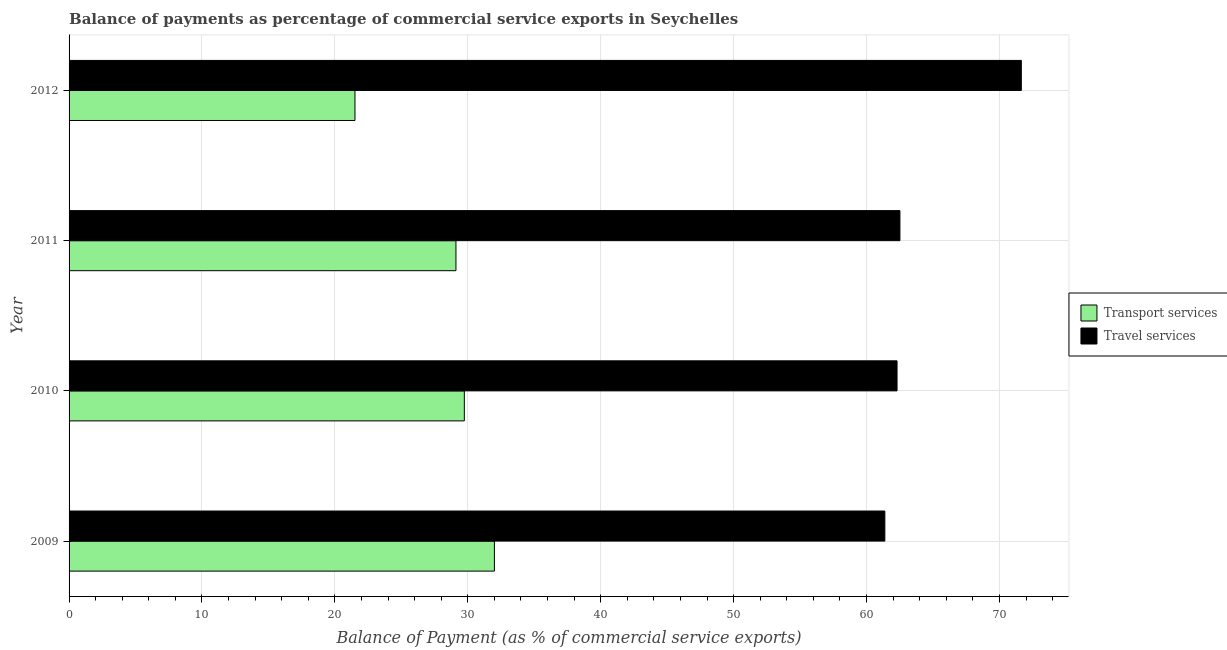How many different coloured bars are there?
Your answer should be compact. 2. Are the number of bars per tick equal to the number of legend labels?
Your answer should be compact. Yes. Are the number of bars on each tick of the Y-axis equal?
Your response must be concise. Yes. How many bars are there on the 3rd tick from the top?
Your answer should be very brief. 2. What is the balance of payments of travel services in 2011?
Your response must be concise. 62.51. Across all years, what is the maximum balance of payments of travel services?
Provide a succinct answer. 71.65. Across all years, what is the minimum balance of payments of travel services?
Provide a succinct answer. 61.38. What is the total balance of payments of transport services in the graph?
Your answer should be very brief. 112.36. What is the difference between the balance of payments of transport services in 2009 and that in 2010?
Keep it short and to the point. 2.26. What is the difference between the balance of payments of travel services in 2012 and the balance of payments of transport services in 2010?
Provide a succinct answer. 41.91. What is the average balance of payments of transport services per year?
Make the answer very short. 28.09. In the year 2011, what is the difference between the balance of payments of travel services and balance of payments of transport services?
Your answer should be very brief. 33.41. In how many years, is the balance of payments of travel services greater than 54 %?
Provide a short and direct response. 4. Is the difference between the balance of payments of transport services in 2011 and 2012 greater than the difference between the balance of payments of travel services in 2011 and 2012?
Your answer should be compact. Yes. What is the difference between the highest and the second highest balance of payments of travel services?
Your answer should be compact. 9.13. What is the difference between the highest and the lowest balance of payments of travel services?
Your answer should be compact. 10.27. In how many years, is the balance of payments of transport services greater than the average balance of payments of transport services taken over all years?
Your answer should be compact. 3. Is the sum of the balance of payments of transport services in 2009 and 2012 greater than the maximum balance of payments of travel services across all years?
Give a very brief answer. No. What does the 1st bar from the top in 2010 represents?
Offer a very short reply. Travel services. What does the 2nd bar from the bottom in 2012 represents?
Your answer should be very brief. Travel services. Are all the bars in the graph horizontal?
Keep it short and to the point. Yes. How many years are there in the graph?
Give a very brief answer. 4. What is the difference between two consecutive major ticks on the X-axis?
Make the answer very short. 10. Are the values on the major ticks of X-axis written in scientific E-notation?
Provide a short and direct response. No. Does the graph contain any zero values?
Provide a short and direct response. No. How many legend labels are there?
Make the answer very short. 2. What is the title of the graph?
Provide a short and direct response. Balance of payments as percentage of commercial service exports in Seychelles. What is the label or title of the X-axis?
Keep it short and to the point. Balance of Payment (as % of commercial service exports). What is the Balance of Payment (as % of commercial service exports) in Transport services in 2009?
Keep it short and to the point. 32. What is the Balance of Payment (as % of commercial service exports) in Travel services in 2009?
Make the answer very short. 61.38. What is the Balance of Payment (as % of commercial service exports) of Transport services in 2010?
Keep it short and to the point. 29.74. What is the Balance of Payment (as % of commercial service exports) in Travel services in 2010?
Ensure brevity in your answer.  62.3. What is the Balance of Payment (as % of commercial service exports) in Transport services in 2011?
Ensure brevity in your answer.  29.11. What is the Balance of Payment (as % of commercial service exports) of Travel services in 2011?
Ensure brevity in your answer.  62.51. What is the Balance of Payment (as % of commercial service exports) of Transport services in 2012?
Your response must be concise. 21.51. What is the Balance of Payment (as % of commercial service exports) of Travel services in 2012?
Ensure brevity in your answer.  71.65. Across all years, what is the maximum Balance of Payment (as % of commercial service exports) of Transport services?
Keep it short and to the point. 32. Across all years, what is the maximum Balance of Payment (as % of commercial service exports) in Travel services?
Offer a terse response. 71.65. Across all years, what is the minimum Balance of Payment (as % of commercial service exports) of Transport services?
Provide a succinct answer. 21.51. Across all years, what is the minimum Balance of Payment (as % of commercial service exports) of Travel services?
Keep it short and to the point. 61.38. What is the total Balance of Payment (as % of commercial service exports) in Transport services in the graph?
Ensure brevity in your answer.  112.36. What is the total Balance of Payment (as % of commercial service exports) in Travel services in the graph?
Your answer should be compact. 257.84. What is the difference between the Balance of Payment (as % of commercial service exports) in Transport services in 2009 and that in 2010?
Give a very brief answer. 2.26. What is the difference between the Balance of Payment (as % of commercial service exports) in Travel services in 2009 and that in 2010?
Ensure brevity in your answer.  -0.92. What is the difference between the Balance of Payment (as % of commercial service exports) of Transport services in 2009 and that in 2011?
Provide a succinct answer. 2.89. What is the difference between the Balance of Payment (as % of commercial service exports) in Travel services in 2009 and that in 2011?
Provide a succinct answer. -1.14. What is the difference between the Balance of Payment (as % of commercial service exports) of Transport services in 2009 and that in 2012?
Your answer should be compact. 10.49. What is the difference between the Balance of Payment (as % of commercial service exports) of Travel services in 2009 and that in 2012?
Ensure brevity in your answer.  -10.27. What is the difference between the Balance of Payment (as % of commercial service exports) of Transport services in 2010 and that in 2011?
Offer a terse response. 0.63. What is the difference between the Balance of Payment (as % of commercial service exports) of Travel services in 2010 and that in 2011?
Provide a short and direct response. -0.22. What is the difference between the Balance of Payment (as % of commercial service exports) in Transport services in 2010 and that in 2012?
Your answer should be very brief. 8.23. What is the difference between the Balance of Payment (as % of commercial service exports) of Travel services in 2010 and that in 2012?
Your answer should be very brief. -9.35. What is the difference between the Balance of Payment (as % of commercial service exports) of Transport services in 2011 and that in 2012?
Offer a terse response. 7.6. What is the difference between the Balance of Payment (as % of commercial service exports) in Travel services in 2011 and that in 2012?
Offer a terse response. -9.13. What is the difference between the Balance of Payment (as % of commercial service exports) in Transport services in 2009 and the Balance of Payment (as % of commercial service exports) in Travel services in 2010?
Make the answer very short. -30.29. What is the difference between the Balance of Payment (as % of commercial service exports) of Transport services in 2009 and the Balance of Payment (as % of commercial service exports) of Travel services in 2011?
Make the answer very short. -30.51. What is the difference between the Balance of Payment (as % of commercial service exports) of Transport services in 2009 and the Balance of Payment (as % of commercial service exports) of Travel services in 2012?
Offer a very short reply. -39.65. What is the difference between the Balance of Payment (as % of commercial service exports) in Transport services in 2010 and the Balance of Payment (as % of commercial service exports) in Travel services in 2011?
Your response must be concise. -32.77. What is the difference between the Balance of Payment (as % of commercial service exports) in Transport services in 2010 and the Balance of Payment (as % of commercial service exports) in Travel services in 2012?
Offer a terse response. -41.91. What is the difference between the Balance of Payment (as % of commercial service exports) of Transport services in 2011 and the Balance of Payment (as % of commercial service exports) of Travel services in 2012?
Your answer should be compact. -42.54. What is the average Balance of Payment (as % of commercial service exports) of Transport services per year?
Your response must be concise. 28.09. What is the average Balance of Payment (as % of commercial service exports) of Travel services per year?
Give a very brief answer. 64.46. In the year 2009, what is the difference between the Balance of Payment (as % of commercial service exports) in Transport services and Balance of Payment (as % of commercial service exports) in Travel services?
Offer a terse response. -29.38. In the year 2010, what is the difference between the Balance of Payment (as % of commercial service exports) of Transport services and Balance of Payment (as % of commercial service exports) of Travel services?
Ensure brevity in your answer.  -32.56. In the year 2011, what is the difference between the Balance of Payment (as % of commercial service exports) in Transport services and Balance of Payment (as % of commercial service exports) in Travel services?
Provide a succinct answer. -33.4. In the year 2012, what is the difference between the Balance of Payment (as % of commercial service exports) of Transport services and Balance of Payment (as % of commercial service exports) of Travel services?
Provide a short and direct response. -50.14. What is the ratio of the Balance of Payment (as % of commercial service exports) in Transport services in 2009 to that in 2010?
Provide a short and direct response. 1.08. What is the ratio of the Balance of Payment (as % of commercial service exports) of Transport services in 2009 to that in 2011?
Your answer should be very brief. 1.1. What is the ratio of the Balance of Payment (as % of commercial service exports) in Travel services in 2009 to that in 2011?
Keep it short and to the point. 0.98. What is the ratio of the Balance of Payment (as % of commercial service exports) in Transport services in 2009 to that in 2012?
Offer a very short reply. 1.49. What is the ratio of the Balance of Payment (as % of commercial service exports) in Travel services in 2009 to that in 2012?
Your answer should be very brief. 0.86. What is the ratio of the Balance of Payment (as % of commercial service exports) of Transport services in 2010 to that in 2011?
Your response must be concise. 1.02. What is the ratio of the Balance of Payment (as % of commercial service exports) in Transport services in 2010 to that in 2012?
Your answer should be compact. 1.38. What is the ratio of the Balance of Payment (as % of commercial service exports) of Travel services in 2010 to that in 2012?
Provide a short and direct response. 0.87. What is the ratio of the Balance of Payment (as % of commercial service exports) in Transport services in 2011 to that in 2012?
Ensure brevity in your answer.  1.35. What is the ratio of the Balance of Payment (as % of commercial service exports) of Travel services in 2011 to that in 2012?
Your response must be concise. 0.87. What is the difference between the highest and the second highest Balance of Payment (as % of commercial service exports) of Transport services?
Give a very brief answer. 2.26. What is the difference between the highest and the second highest Balance of Payment (as % of commercial service exports) in Travel services?
Your response must be concise. 9.13. What is the difference between the highest and the lowest Balance of Payment (as % of commercial service exports) in Transport services?
Make the answer very short. 10.49. What is the difference between the highest and the lowest Balance of Payment (as % of commercial service exports) of Travel services?
Your answer should be very brief. 10.27. 